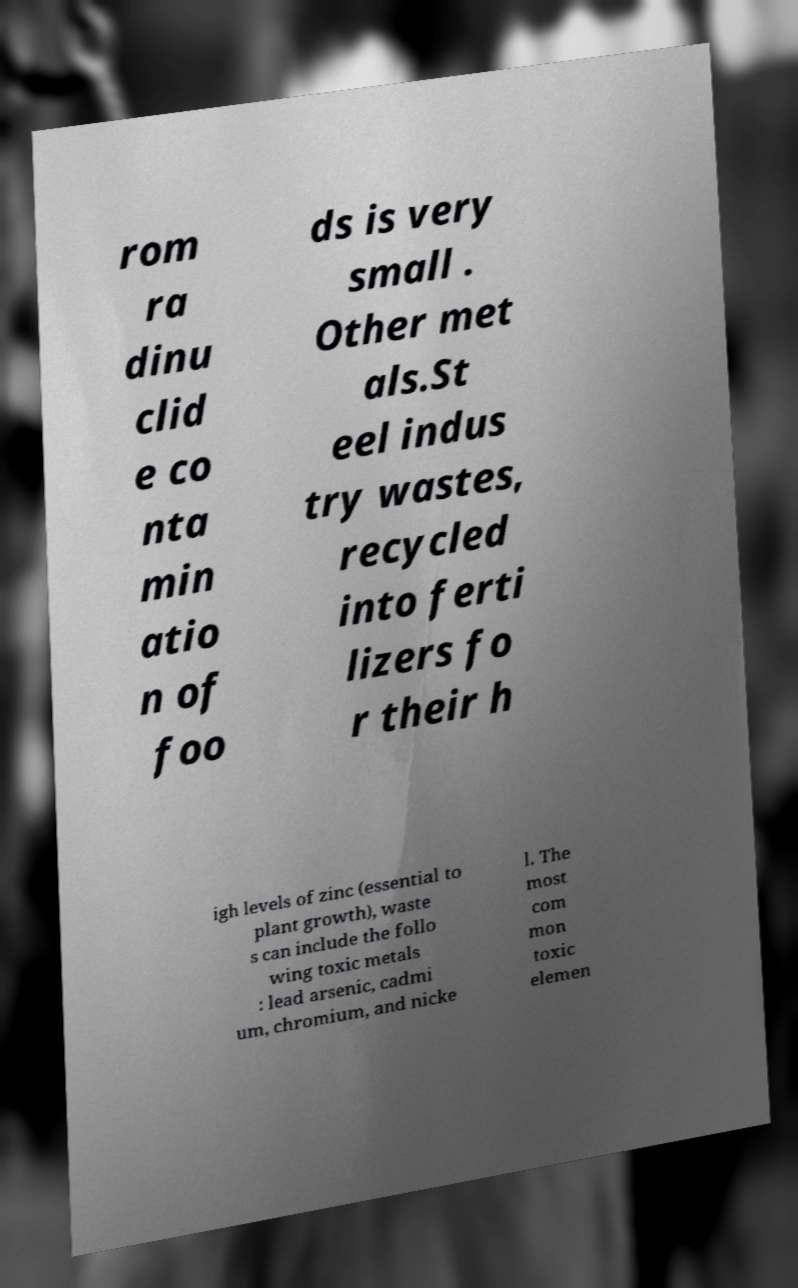There's text embedded in this image that I need extracted. Can you transcribe it verbatim? rom ra dinu clid e co nta min atio n of foo ds is very small . Other met als.St eel indus try wastes, recycled into ferti lizers fo r their h igh levels of zinc (essential to plant growth), waste s can include the follo wing toxic metals : lead arsenic, cadmi um, chromium, and nicke l. The most com mon toxic elemen 